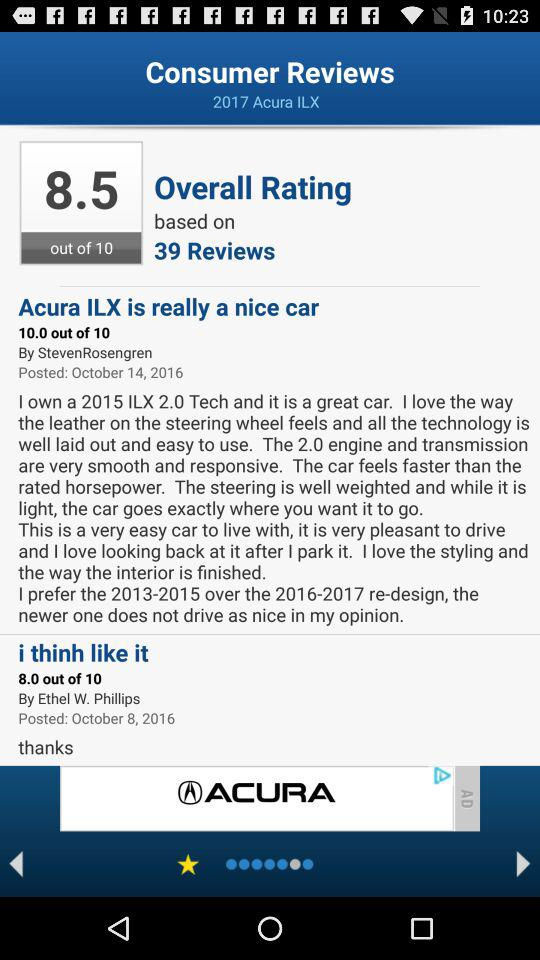How many reviews are there for the Acura ILX?
Answer the question using a single word or phrase. 39 